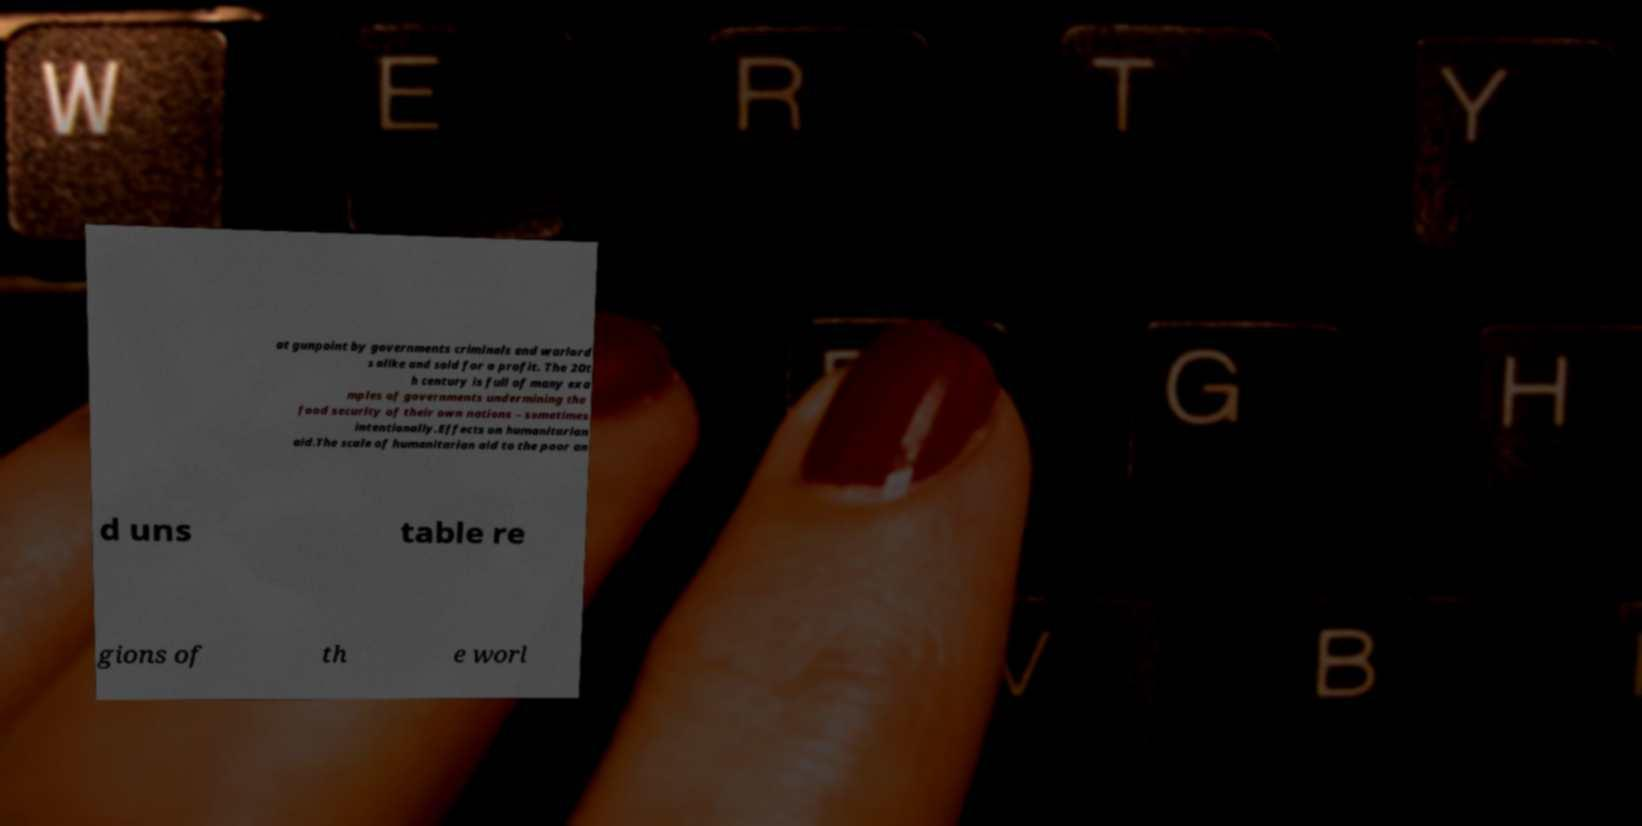Can you accurately transcribe the text from the provided image for me? at gunpoint by governments criminals and warlord s alike and sold for a profit. The 20t h century is full of many exa mples of governments undermining the food security of their own nations – sometimes intentionally.Effects on humanitarian aid.The scale of humanitarian aid to the poor an d uns table re gions of th e worl 